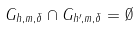Convert formula to latex. <formula><loc_0><loc_0><loc_500><loc_500>G _ { h , m , \delta } \cap G _ { h ^ { \prime } , m , \delta } = \emptyset</formula> 